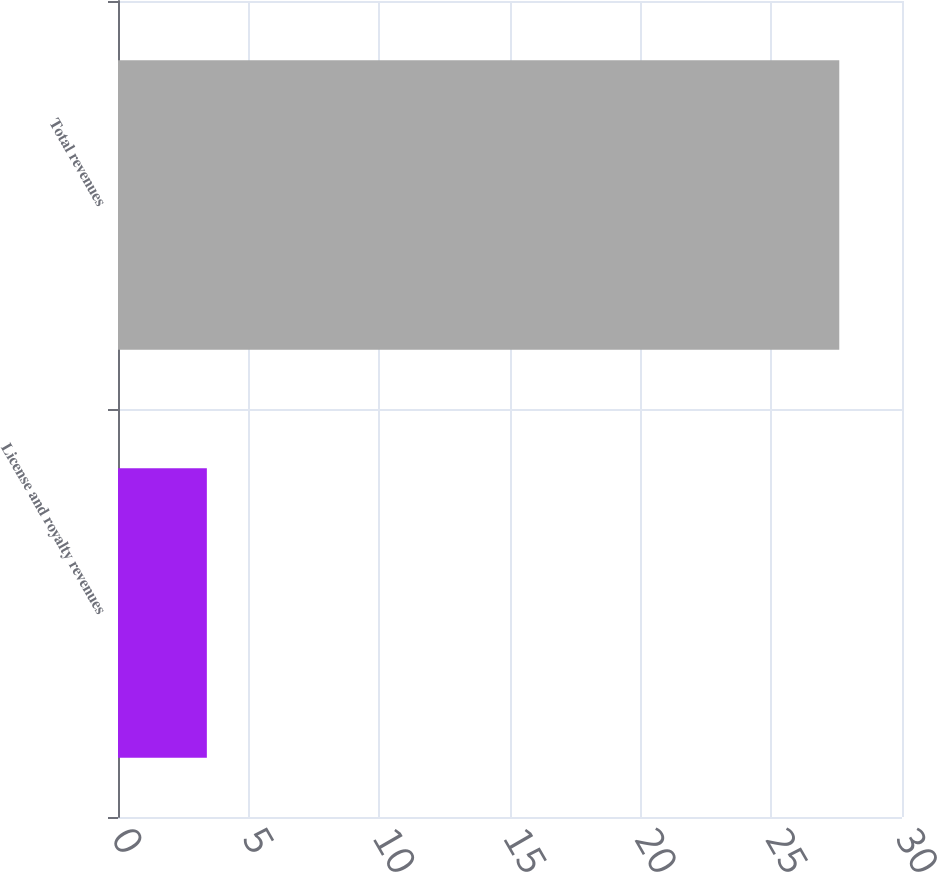Convert chart to OTSL. <chart><loc_0><loc_0><loc_500><loc_500><bar_chart><fcel>License and royalty revenues<fcel>Total revenues<nl><fcel>3.4<fcel>27.6<nl></chart> 